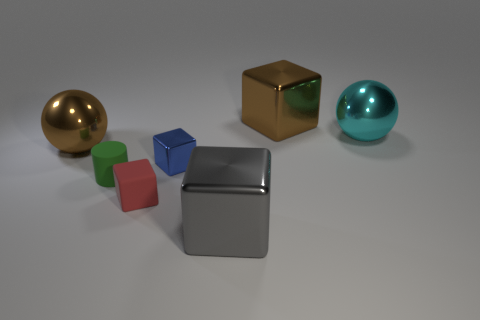Subtract 1 cubes. How many cubes are left? 3 Subtract all red cubes. Subtract all red spheres. How many cubes are left? 3 Add 2 tiny spheres. How many objects exist? 9 Subtract all blocks. How many objects are left? 3 Add 3 tiny blue metal objects. How many tiny blue metal objects exist? 4 Subtract 0 gray cylinders. How many objects are left? 7 Subtract all large metallic cubes. Subtract all tiny rubber cubes. How many objects are left? 4 Add 1 brown balls. How many brown balls are left? 2 